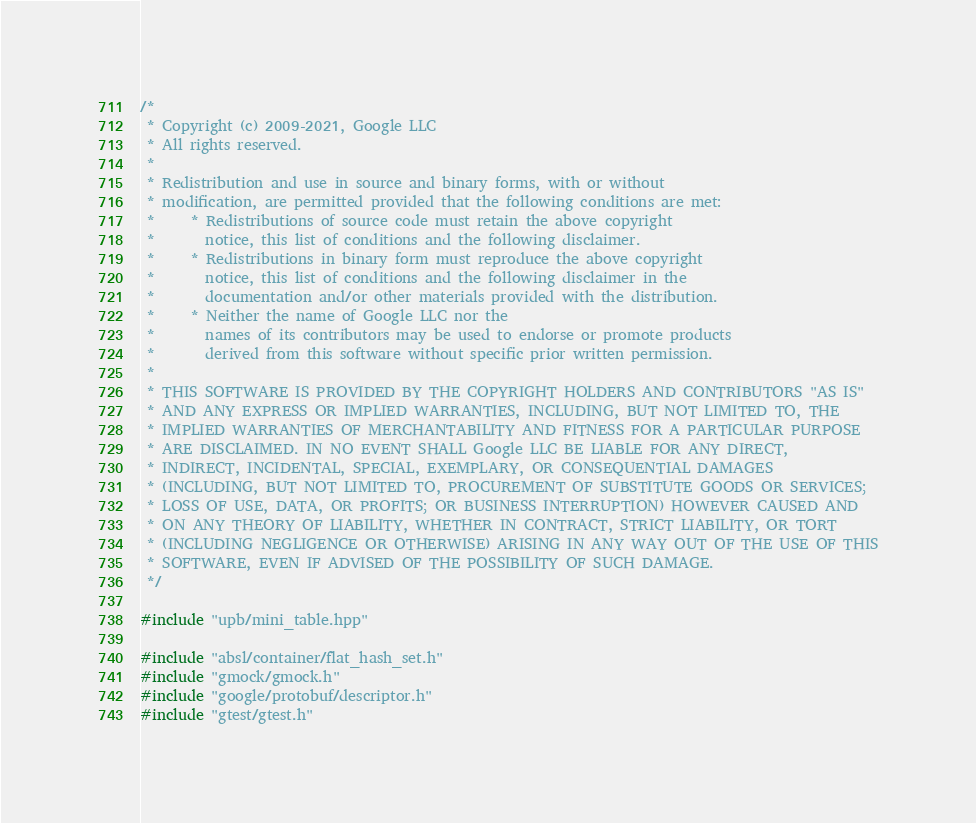Convert code to text. <code><loc_0><loc_0><loc_500><loc_500><_C++_>/*
 * Copyright (c) 2009-2021, Google LLC
 * All rights reserved.
 *
 * Redistribution and use in source and binary forms, with or without
 * modification, are permitted provided that the following conditions are met:
 *     * Redistributions of source code must retain the above copyright
 *       notice, this list of conditions and the following disclaimer.
 *     * Redistributions in binary form must reproduce the above copyright
 *       notice, this list of conditions and the following disclaimer in the
 *       documentation and/or other materials provided with the distribution.
 *     * Neither the name of Google LLC nor the
 *       names of its contributors may be used to endorse or promote products
 *       derived from this software without specific prior written permission.
 *
 * THIS SOFTWARE IS PROVIDED BY THE COPYRIGHT HOLDERS AND CONTRIBUTORS "AS IS"
 * AND ANY EXPRESS OR IMPLIED WARRANTIES, INCLUDING, BUT NOT LIMITED TO, THE
 * IMPLIED WARRANTIES OF MERCHANTABILITY AND FITNESS FOR A PARTICULAR PURPOSE
 * ARE DISCLAIMED. IN NO EVENT SHALL Google LLC BE LIABLE FOR ANY DIRECT,
 * INDIRECT, INCIDENTAL, SPECIAL, EXEMPLARY, OR CONSEQUENTIAL DAMAGES
 * (INCLUDING, BUT NOT LIMITED TO, PROCUREMENT OF SUBSTITUTE GOODS OR SERVICES;
 * LOSS OF USE, DATA, OR PROFITS; OR BUSINESS INTERRUPTION) HOWEVER CAUSED AND
 * ON ANY THEORY OF LIABILITY, WHETHER IN CONTRACT, STRICT LIABILITY, OR TORT
 * (INCLUDING NEGLIGENCE OR OTHERWISE) ARISING IN ANY WAY OUT OF THE USE OF THIS
 * SOFTWARE, EVEN IF ADVISED OF THE POSSIBILITY OF SUCH DAMAGE.
 */

#include "upb/mini_table.hpp"

#include "absl/container/flat_hash_set.h"
#include "gmock/gmock.h"
#include "google/protobuf/descriptor.h"
#include "gtest/gtest.h"</code> 